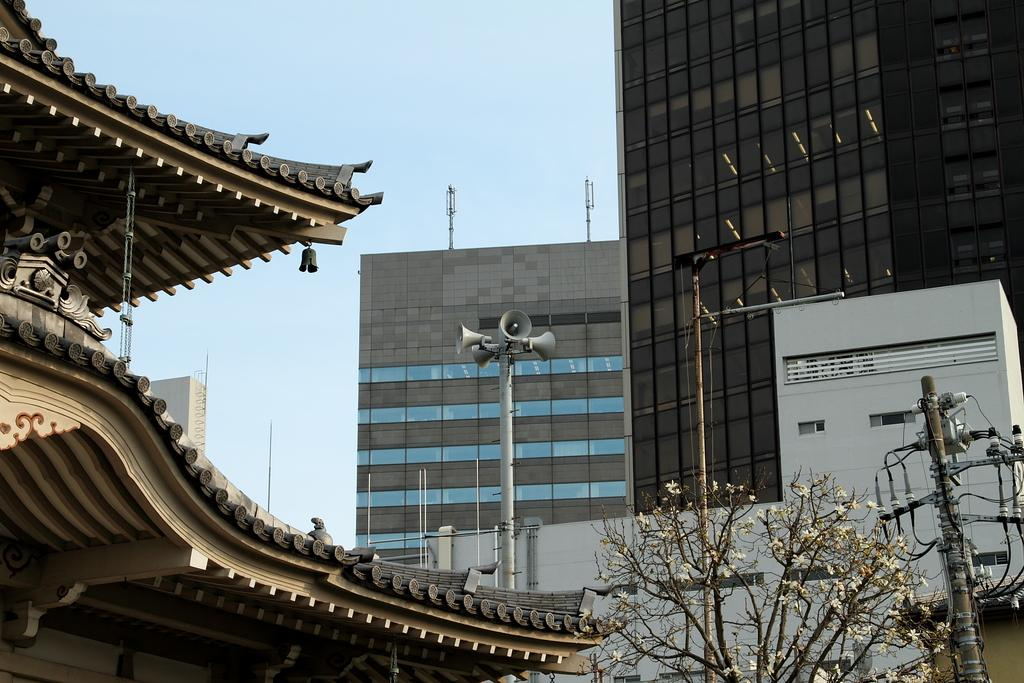What type of structures are visible in the image? There are buildings in the image. What can be seen on top of the buildings? There are antennas on top of the buildings. What type of vegetation is present in the image? There are trees in the image. What other man-made structures can be seen in the image? There are electric poles in the image. Can you describe a specific pole in the image? There is a pole with speakers in the image. What type of badge is being worn by the tree in the image? There are no badges present in the image, as the trees are not wearing any accessories. How many days have passed since the kettle was last used in the image? There is no kettle present in the image, so it is not possible to determine when it was last used. 